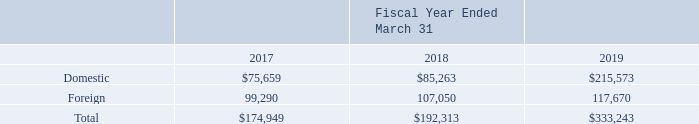10. Income Taxes:
For financial reporting purposes, income before income taxes included the following components:
What is the company's total income before income taxes for the fiscal year ended March 31, 2019? 333,243. What is the company's total income before income taxes for the fiscal year ended March 31, 2018? 192,313. What is the company's total income before income taxes for the fiscal year ended March 31, 2017? 174,949. What is the proportion of the domestic income as a percentage of the total income in 2019?
Answer scale should be: percent. 215,573/333,243 
Answer: 64.69. What is the change in total income before income taxes between 2017 and 2018? 192,313 - 174,949 
Answer: 17364. What is the percentage change in total income between 2018 and 2019?
Answer scale should be: percent. (333,243 - 192,313)/192,313 
Answer: 73.28. 